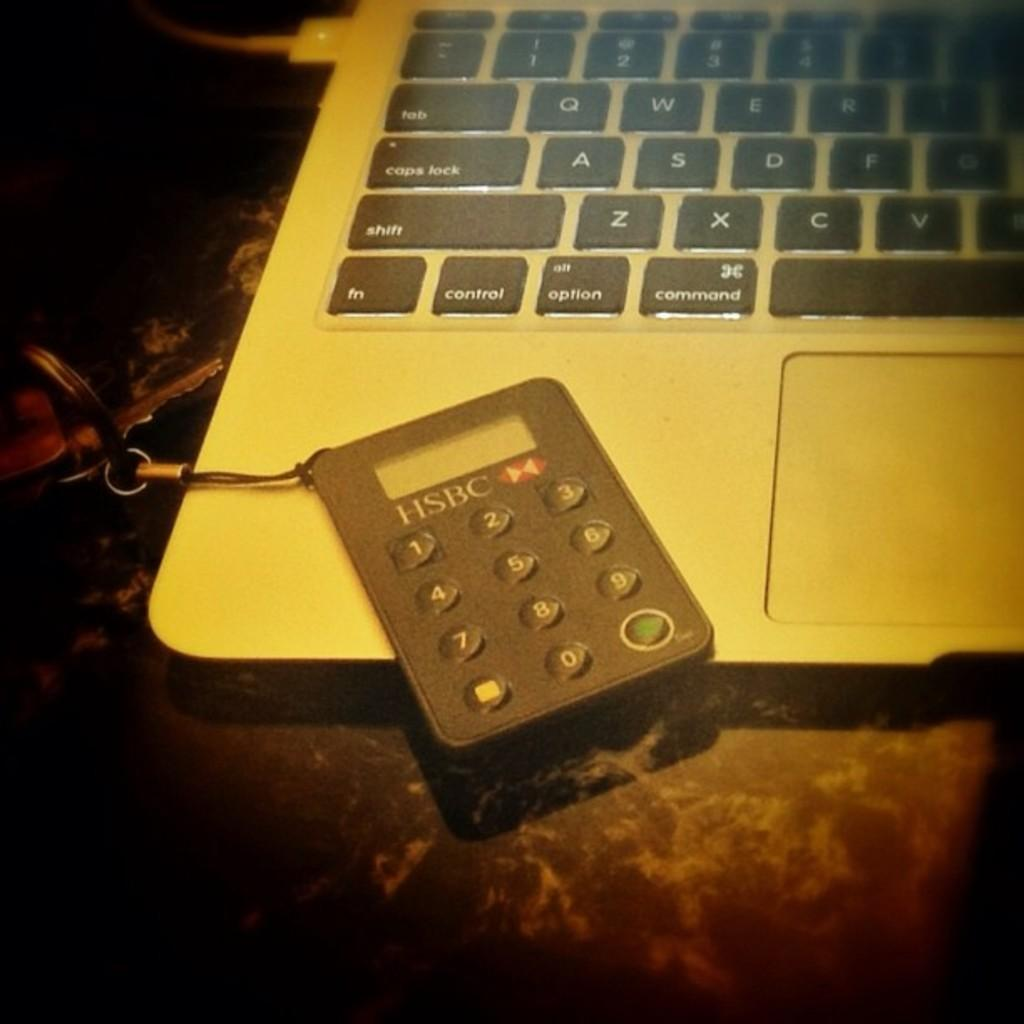<image>
Render a clear and concise summary of the photo. HSBC numbad on top of a silver laptop. 